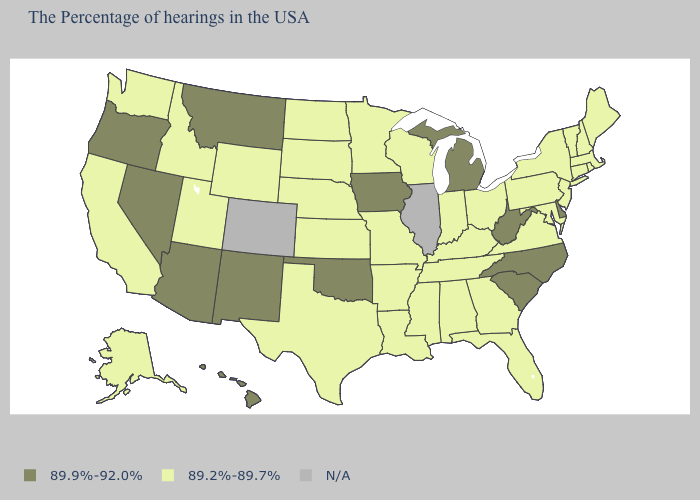What is the lowest value in states that border South Carolina?
Quick response, please. 89.2%-89.7%. Does Hawaii have the highest value in the West?
Give a very brief answer. Yes. What is the value of Pennsylvania?
Short answer required. 89.2%-89.7%. What is the value of Kansas?
Give a very brief answer. 89.2%-89.7%. What is the value of Connecticut?
Keep it brief. 89.2%-89.7%. What is the lowest value in the West?
Write a very short answer. 89.2%-89.7%. Name the states that have a value in the range N/A?
Concise answer only. Illinois, Colorado. What is the lowest value in the Northeast?
Write a very short answer. 89.2%-89.7%. What is the highest value in states that border Alabama?
Answer briefly. 89.2%-89.7%. Is the legend a continuous bar?
Keep it brief. No. What is the lowest value in the USA?
Write a very short answer. 89.2%-89.7%. What is the highest value in the USA?
Concise answer only. 89.9%-92.0%. 